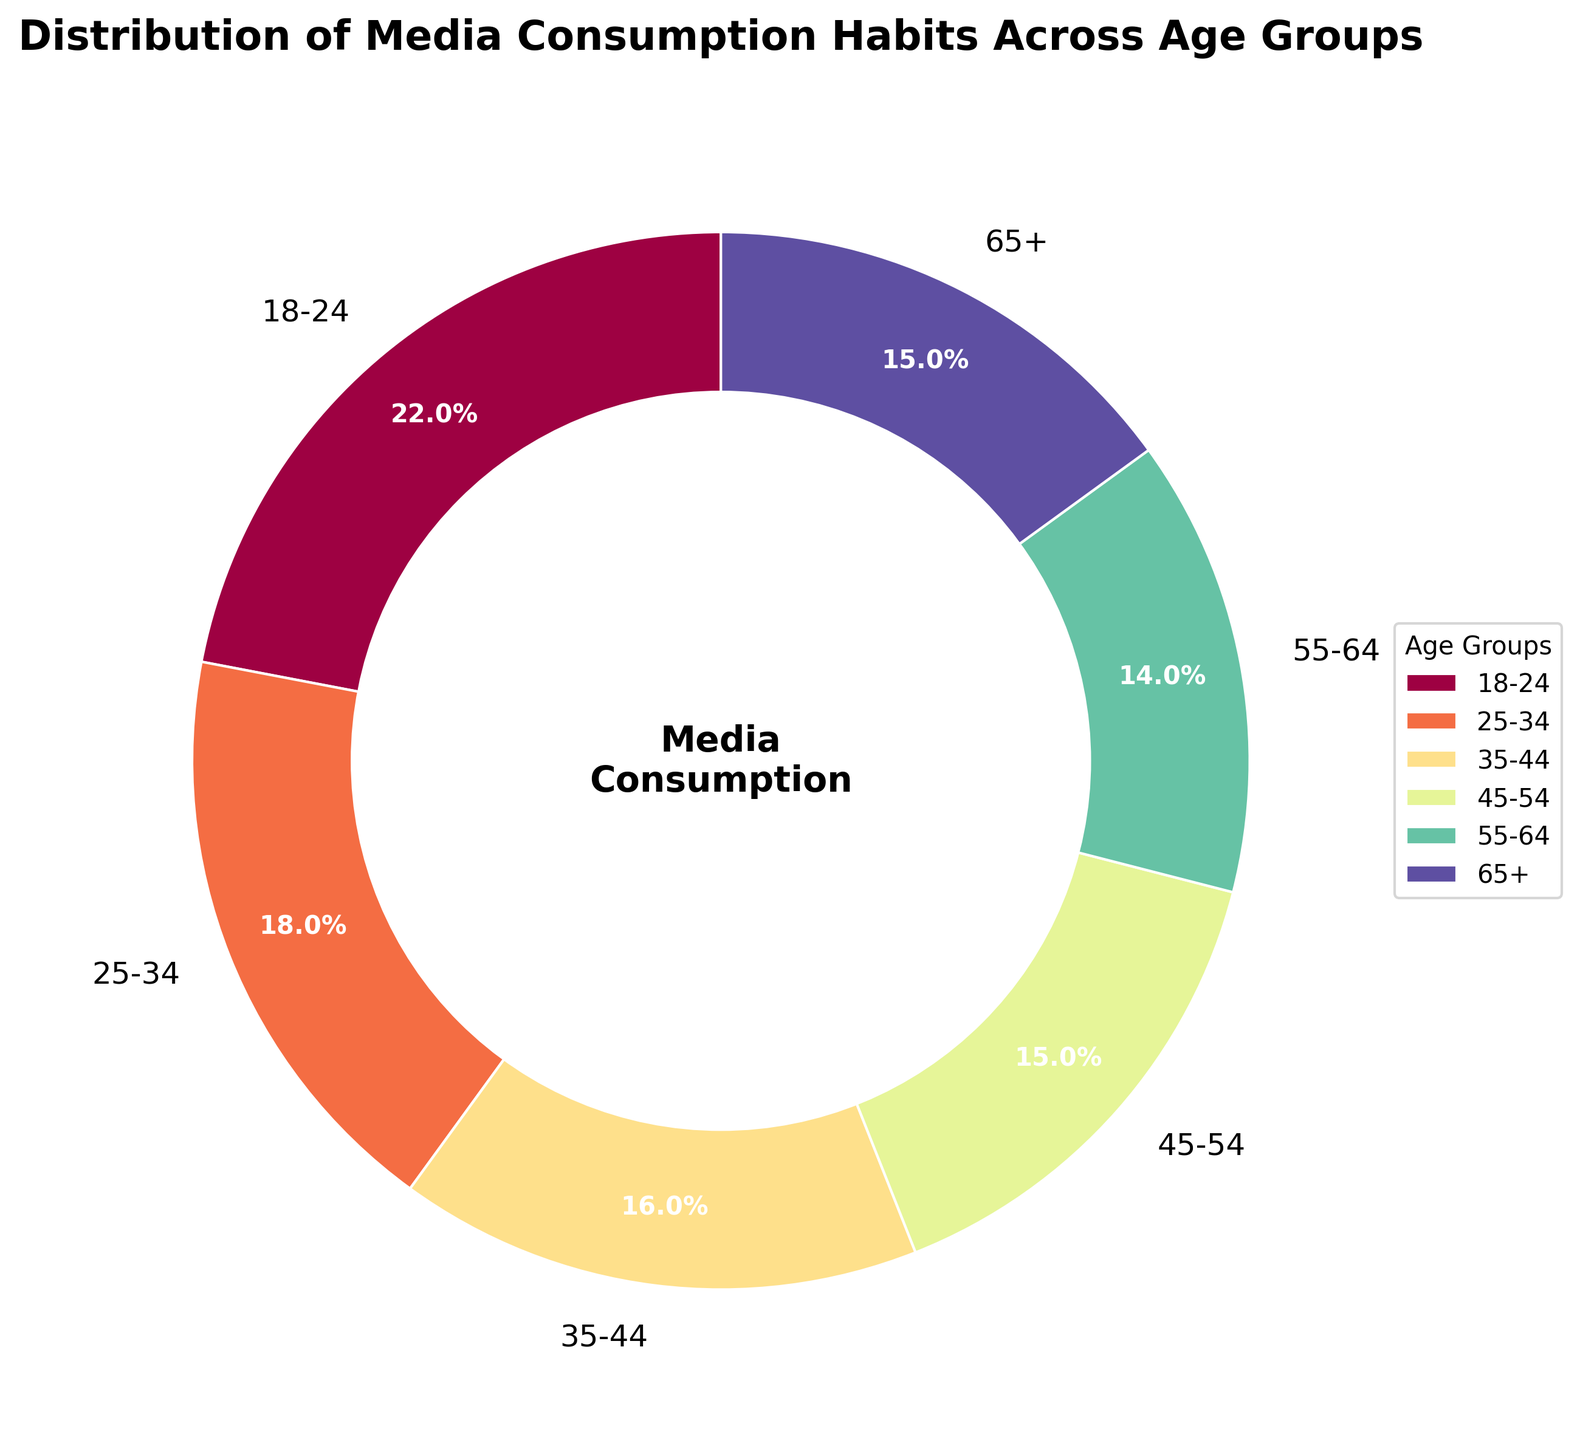What age group has the highest percentage of media consumption? The figure shows a pie chart with percentages for different age groups. By observing the size of the wedges and the corresponding labels, the largest wedge corresponds to the 18-24 age group. This group has the highest percentage of media consumption at 22%.
Answer: 18-24 Which two age groups have an equal percentage of media consumption? By examining the figure, we can see that both the 45-54 and 65+ age groups have wedges of the same size, each labeled with 15%. Therefore, these two age groups have equal percentages of media consumption.
Answer: 45-54 and 65+ What is the combined percentage of media consumption for people aged 35-54? To find the combined percentage, we sum the percentages for the age groups 35-44 and 45-54. From the figure: 16% (35-44) + 15% (45-54) = 31%.
Answer: 31% Is the media consumption percentage of the 18-24 age group greater than that of the 55-64 age group? The figure shows that the 18-24 age group has a percentage of 22%, while the 55-64 age group has 14%. Since 22% is greater than 14%, the media consumption percentage for the 18-24 age group is indeed greater.
Answer: Yes What percentage of media consumption is represented by age groups under 35 years old? To calculate this, we sum the percentages for the age groups 18-24 and 25-34. From the figure: 22% (18-24) + 18% (25-34) = 40%.
Answer: 40% Which age group has the smallest percentage of media consumption? By reviewing the figure and comparing the size of the wedges, the 55-64 age group has the smallest wedge labeled with 14%. This is the smallest percentage of media consumption among all the age groups.
Answer: 55-64 What percentage of media consumption does the 65+ age group contribute? According to the figure, the wedge corresponding to the 65+ age group is labeled with 15%. Thus, the 65+ age group contributes 15% to media consumption.
Answer: 15% How do the percentages of media consumption for the 25-34 and 35-44 age groups compare? The figure shows that the 25-34 age group has a percentage of 18%, while the 35-44 age group has a percentage of 16%. Therefore, the media consumption percentage for the 25-34 age group is higher.
Answer: 25-34 > 35-44 What is the difference in media consumption percentages between the 18-24 and 35-44 age groups? We subtract the percentage for the 35-44 age group from the percentage for the 18-24 age group: 22% (18-24) - 16% (35-44) = 6%.
Answer: 6% Which age group is represented by the green wedge in the pie chart? In the figure, if the green wedge corresponds to a specific age group, we can identify it based on its label. However, since we don't specify the exact color mapping in the visual description, this information isn't directly obtainable here. Users would need to refer to the pie chart legend to confirm the color mapping.
Answer: Depends on the legend 